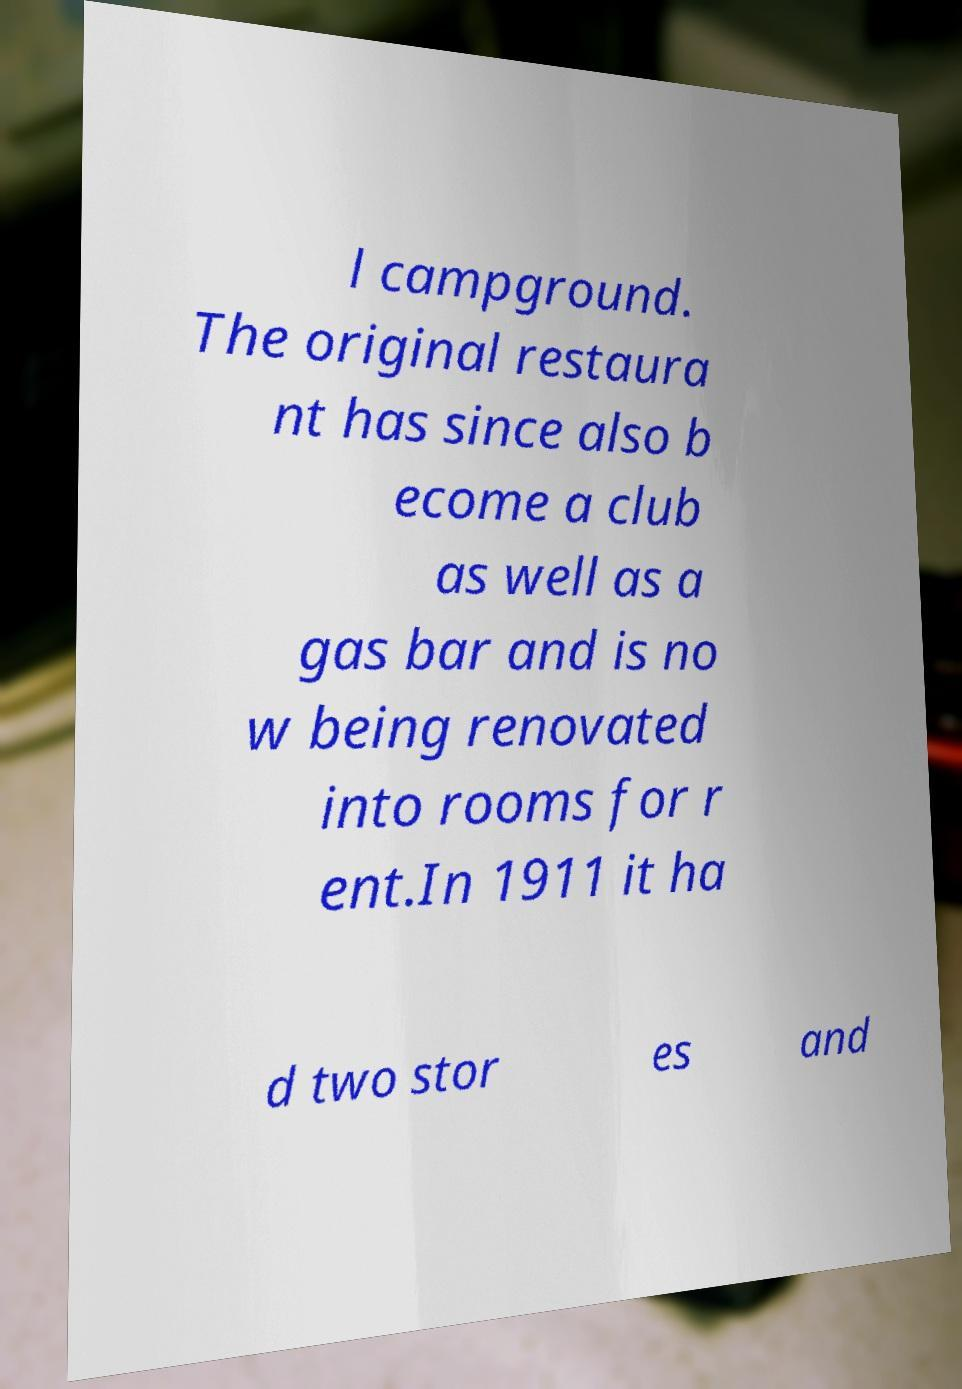For documentation purposes, I need the text within this image transcribed. Could you provide that? l campground. The original restaura nt has since also b ecome a club as well as a gas bar and is no w being renovated into rooms for r ent.In 1911 it ha d two stor es and 